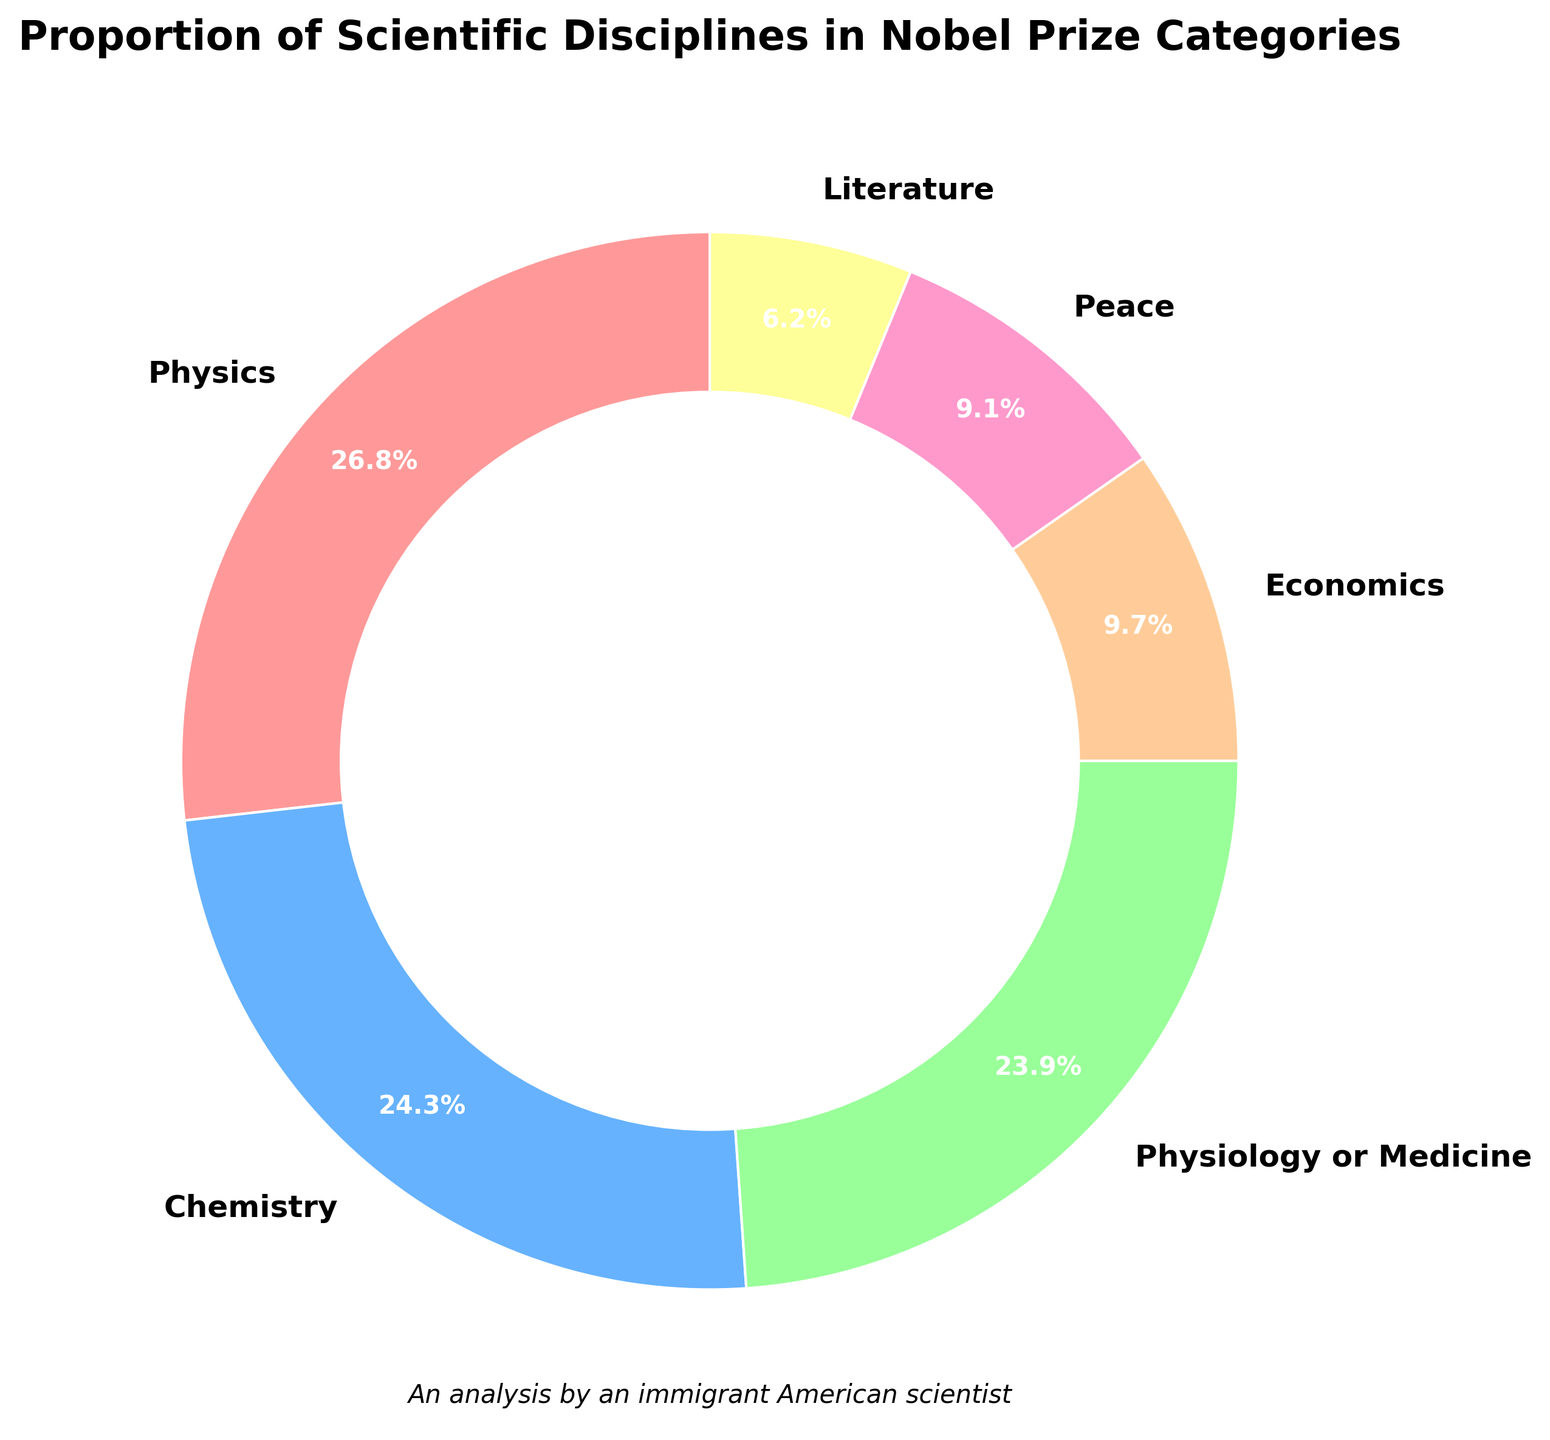What's the most represented scientific discipline in Nobel Prize categories? From the pie chart, we observe that Physics has the largest slice of the pie.
Answer: Physics Which two scientific disciplines have almost equal proportions? By comparing the sizes of the slices, Chemistry and Physiology or Medicine have nearly similar percentages, both approximately around 24-25%.
Answer: Chemistry and Physiology or Medicine What is the sum of the percentages for Peace and Literature categories? Adding the percentages for Peace (9.1) and Literature (6.2): 9.1 + 6.2 = 15.3
Answer: 15.3 How much more represented is Physics compared to Literature? Subtracting the percentages of Literature from Physics: 26.8 - 6.2 = 20.6
Answer: 20.6 What percentage of the Nobel Prize categories is accounted for by the Economics category? The pie chart indicates that the Economics category accounts for 9.7%.
Answer: 9.7% Which category has a smaller representation than Physiology or Medicine but larger than Literature? Economics, with a percentage of 9.7%, fits between Physiology or Medicine (23.9%) and Literature (6.2%).
Answer: Economics If you combine the percentages of Peace, Literature, and Economics, does their total exceed the percentage of any single category from Physics, Chemistry, or Physiology or Medicine? Adding the percentages: Peace (9.1) + Literature (6.2) + Economics (9.7) = 25. Their total (25) is less than Physics (26.8) but more than Chemistry (24.3) or Physiology or Medicine (23.9).
Answer: Yes, Chemistry and Physiology or Medicine Which category represented in the Nobel Prize categories is closest in percentage to 10%? Economics, with a percentage of 9.7%, is the closest to 10%.
Answer: Economics In terms of percentage, which scientific discipline is least represented among the Nobel Prize categories? Literature, with a percentage of 6.2%, has the smallest representation.
Answer: Literature 